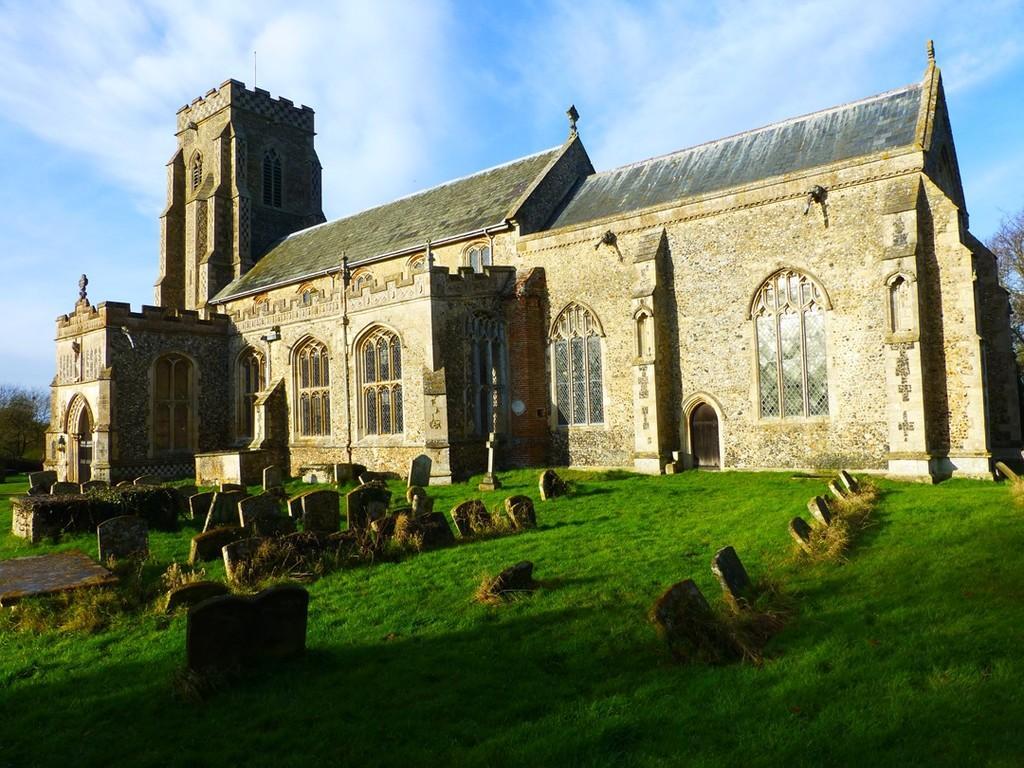In one or two sentences, can you explain what this image depicts? In the image we can see there is ground covered with grass and there is graveyard. Behind there is a building and there are trees. There is a cloudy sky. 